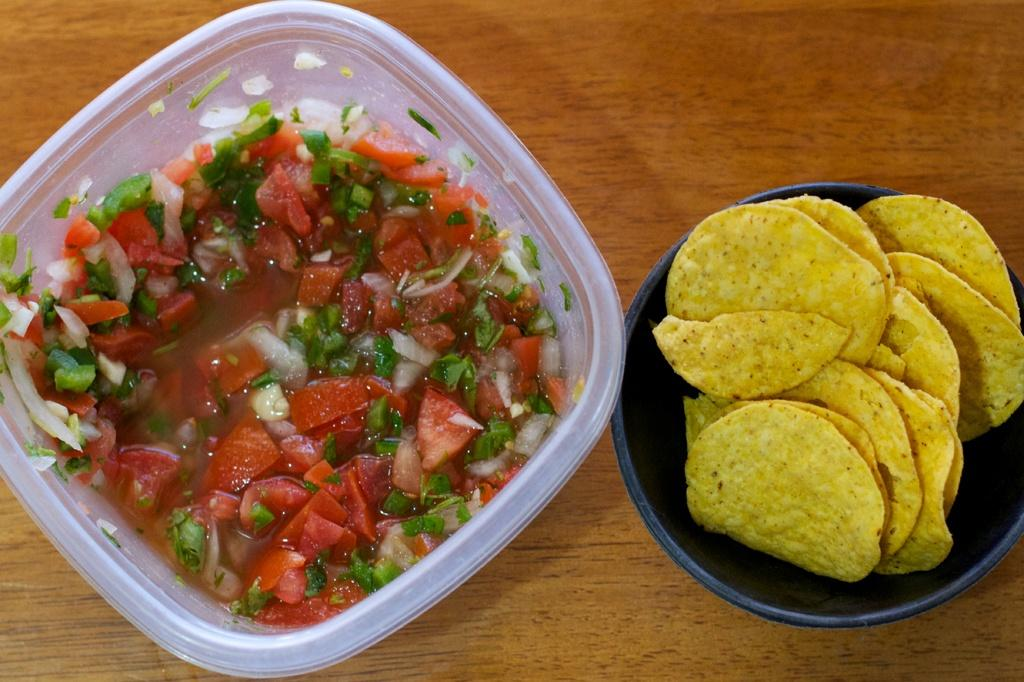How many bowls are visible in the image? There are two bowls in the image. What is in the bowls that are visible in the image? The bowls contain food items. Where are the bowls located in the image? The bowls are placed on a table. Can you see the parent holding the hands of the children while they eat the apples in the image? There is no reference to a parent, children, or apples in the image; it only features two bowls containing food items placed on a table. 